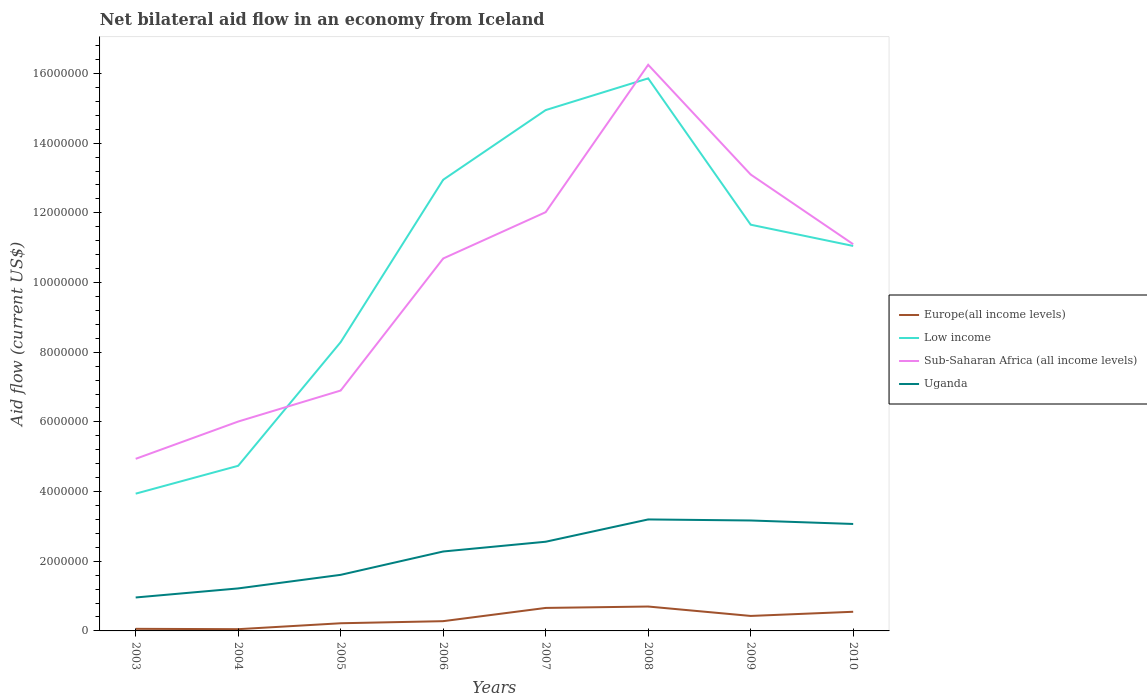How many different coloured lines are there?
Provide a succinct answer. 4. Does the line corresponding to Uganda intersect with the line corresponding to Europe(all income levels)?
Keep it short and to the point. No. Across all years, what is the maximum net bilateral aid flow in Uganda?
Offer a very short reply. 9.60e+05. In which year was the net bilateral aid flow in Uganda maximum?
Provide a short and direct response. 2003. What is the difference between the highest and the second highest net bilateral aid flow in Low income?
Ensure brevity in your answer.  1.19e+07. What is the difference between the highest and the lowest net bilateral aid flow in Uganda?
Offer a terse response. 5. Is the net bilateral aid flow in Low income strictly greater than the net bilateral aid flow in Europe(all income levels) over the years?
Provide a short and direct response. No. How many lines are there?
Your answer should be very brief. 4. How many years are there in the graph?
Provide a short and direct response. 8. Does the graph contain any zero values?
Give a very brief answer. No. Does the graph contain grids?
Give a very brief answer. No. How many legend labels are there?
Offer a very short reply. 4. How are the legend labels stacked?
Provide a succinct answer. Vertical. What is the title of the graph?
Offer a terse response. Net bilateral aid flow in an economy from Iceland. What is the Aid flow (current US$) of Low income in 2003?
Your response must be concise. 3.94e+06. What is the Aid flow (current US$) of Sub-Saharan Africa (all income levels) in 2003?
Offer a terse response. 4.94e+06. What is the Aid flow (current US$) in Uganda in 2003?
Provide a short and direct response. 9.60e+05. What is the Aid flow (current US$) of Low income in 2004?
Make the answer very short. 4.74e+06. What is the Aid flow (current US$) in Sub-Saharan Africa (all income levels) in 2004?
Ensure brevity in your answer.  6.01e+06. What is the Aid flow (current US$) of Uganda in 2004?
Your answer should be compact. 1.22e+06. What is the Aid flow (current US$) of Europe(all income levels) in 2005?
Ensure brevity in your answer.  2.20e+05. What is the Aid flow (current US$) in Low income in 2005?
Ensure brevity in your answer.  8.29e+06. What is the Aid flow (current US$) of Sub-Saharan Africa (all income levels) in 2005?
Your response must be concise. 6.90e+06. What is the Aid flow (current US$) in Uganda in 2005?
Provide a succinct answer. 1.61e+06. What is the Aid flow (current US$) of Europe(all income levels) in 2006?
Give a very brief answer. 2.80e+05. What is the Aid flow (current US$) of Low income in 2006?
Keep it short and to the point. 1.30e+07. What is the Aid flow (current US$) in Sub-Saharan Africa (all income levels) in 2006?
Your answer should be compact. 1.07e+07. What is the Aid flow (current US$) of Uganda in 2006?
Offer a terse response. 2.28e+06. What is the Aid flow (current US$) in Europe(all income levels) in 2007?
Keep it short and to the point. 6.60e+05. What is the Aid flow (current US$) of Low income in 2007?
Give a very brief answer. 1.50e+07. What is the Aid flow (current US$) in Sub-Saharan Africa (all income levels) in 2007?
Keep it short and to the point. 1.20e+07. What is the Aid flow (current US$) of Uganda in 2007?
Keep it short and to the point. 2.56e+06. What is the Aid flow (current US$) in Low income in 2008?
Make the answer very short. 1.59e+07. What is the Aid flow (current US$) in Sub-Saharan Africa (all income levels) in 2008?
Your response must be concise. 1.62e+07. What is the Aid flow (current US$) of Uganda in 2008?
Provide a short and direct response. 3.20e+06. What is the Aid flow (current US$) of Low income in 2009?
Your answer should be very brief. 1.17e+07. What is the Aid flow (current US$) of Sub-Saharan Africa (all income levels) in 2009?
Your answer should be compact. 1.31e+07. What is the Aid flow (current US$) of Uganda in 2009?
Your answer should be very brief. 3.17e+06. What is the Aid flow (current US$) of Europe(all income levels) in 2010?
Your answer should be very brief. 5.50e+05. What is the Aid flow (current US$) of Low income in 2010?
Give a very brief answer. 1.10e+07. What is the Aid flow (current US$) in Sub-Saharan Africa (all income levels) in 2010?
Keep it short and to the point. 1.11e+07. What is the Aid flow (current US$) of Uganda in 2010?
Your answer should be very brief. 3.07e+06. Across all years, what is the maximum Aid flow (current US$) of Europe(all income levels)?
Provide a succinct answer. 7.00e+05. Across all years, what is the maximum Aid flow (current US$) in Low income?
Your answer should be very brief. 1.59e+07. Across all years, what is the maximum Aid flow (current US$) in Sub-Saharan Africa (all income levels)?
Offer a terse response. 1.62e+07. Across all years, what is the maximum Aid flow (current US$) of Uganda?
Ensure brevity in your answer.  3.20e+06. Across all years, what is the minimum Aid flow (current US$) of Europe(all income levels)?
Your answer should be compact. 5.00e+04. Across all years, what is the minimum Aid flow (current US$) in Low income?
Provide a succinct answer. 3.94e+06. Across all years, what is the minimum Aid flow (current US$) in Sub-Saharan Africa (all income levels)?
Your answer should be very brief. 4.94e+06. Across all years, what is the minimum Aid flow (current US$) in Uganda?
Give a very brief answer. 9.60e+05. What is the total Aid flow (current US$) in Europe(all income levels) in the graph?
Give a very brief answer. 2.95e+06. What is the total Aid flow (current US$) of Low income in the graph?
Make the answer very short. 8.34e+07. What is the total Aid flow (current US$) of Sub-Saharan Africa (all income levels) in the graph?
Your answer should be compact. 8.10e+07. What is the total Aid flow (current US$) in Uganda in the graph?
Your answer should be compact. 1.81e+07. What is the difference between the Aid flow (current US$) in Low income in 2003 and that in 2004?
Your answer should be compact. -8.00e+05. What is the difference between the Aid flow (current US$) in Sub-Saharan Africa (all income levels) in 2003 and that in 2004?
Ensure brevity in your answer.  -1.07e+06. What is the difference between the Aid flow (current US$) in Europe(all income levels) in 2003 and that in 2005?
Provide a succinct answer. -1.60e+05. What is the difference between the Aid flow (current US$) of Low income in 2003 and that in 2005?
Your answer should be very brief. -4.35e+06. What is the difference between the Aid flow (current US$) of Sub-Saharan Africa (all income levels) in 2003 and that in 2005?
Make the answer very short. -1.96e+06. What is the difference between the Aid flow (current US$) in Uganda in 2003 and that in 2005?
Offer a very short reply. -6.50e+05. What is the difference between the Aid flow (current US$) of Low income in 2003 and that in 2006?
Ensure brevity in your answer.  -9.01e+06. What is the difference between the Aid flow (current US$) of Sub-Saharan Africa (all income levels) in 2003 and that in 2006?
Give a very brief answer. -5.75e+06. What is the difference between the Aid flow (current US$) in Uganda in 2003 and that in 2006?
Your response must be concise. -1.32e+06. What is the difference between the Aid flow (current US$) of Europe(all income levels) in 2003 and that in 2007?
Your response must be concise. -6.00e+05. What is the difference between the Aid flow (current US$) in Low income in 2003 and that in 2007?
Offer a terse response. -1.10e+07. What is the difference between the Aid flow (current US$) of Sub-Saharan Africa (all income levels) in 2003 and that in 2007?
Your answer should be compact. -7.08e+06. What is the difference between the Aid flow (current US$) of Uganda in 2003 and that in 2007?
Make the answer very short. -1.60e+06. What is the difference between the Aid flow (current US$) in Europe(all income levels) in 2003 and that in 2008?
Offer a very short reply. -6.40e+05. What is the difference between the Aid flow (current US$) of Low income in 2003 and that in 2008?
Your response must be concise. -1.19e+07. What is the difference between the Aid flow (current US$) in Sub-Saharan Africa (all income levels) in 2003 and that in 2008?
Provide a succinct answer. -1.13e+07. What is the difference between the Aid flow (current US$) of Uganda in 2003 and that in 2008?
Keep it short and to the point. -2.24e+06. What is the difference between the Aid flow (current US$) in Europe(all income levels) in 2003 and that in 2009?
Offer a terse response. -3.70e+05. What is the difference between the Aid flow (current US$) of Low income in 2003 and that in 2009?
Keep it short and to the point. -7.72e+06. What is the difference between the Aid flow (current US$) of Sub-Saharan Africa (all income levels) in 2003 and that in 2009?
Ensure brevity in your answer.  -8.16e+06. What is the difference between the Aid flow (current US$) in Uganda in 2003 and that in 2009?
Provide a succinct answer. -2.21e+06. What is the difference between the Aid flow (current US$) of Europe(all income levels) in 2003 and that in 2010?
Keep it short and to the point. -4.90e+05. What is the difference between the Aid flow (current US$) of Low income in 2003 and that in 2010?
Make the answer very short. -7.11e+06. What is the difference between the Aid flow (current US$) in Sub-Saharan Africa (all income levels) in 2003 and that in 2010?
Provide a succinct answer. -6.16e+06. What is the difference between the Aid flow (current US$) of Uganda in 2003 and that in 2010?
Provide a short and direct response. -2.11e+06. What is the difference between the Aid flow (current US$) in Europe(all income levels) in 2004 and that in 2005?
Make the answer very short. -1.70e+05. What is the difference between the Aid flow (current US$) in Low income in 2004 and that in 2005?
Your answer should be compact. -3.55e+06. What is the difference between the Aid flow (current US$) in Sub-Saharan Africa (all income levels) in 2004 and that in 2005?
Offer a very short reply. -8.90e+05. What is the difference between the Aid flow (current US$) of Uganda in 2004 and that in 2005?
Offer a terse response. -3.90e+05. What is the difference between the Aid flow (current US$) of Low income in 2004 and that in 2006?
Your response must be concise. -8.21e+06. What is the difference between the Aid flow (current US$) of Sub-Saharan Africa (all income levels) in 2004 and that in 2006?
Give a very brief answer. -4.68e+06. What is the difference between the Aid flow (current US$) in Uganda in 2004 and that in 2006?
Keep it short and to the point. -1.06e+06. What is the difference between the Aid flow (current US$) of Europe(all income levels) in 2004 and that in 2007?
Your response must be concise. -6.10e+05. What is the difference between the Aid flow (current US$) of Low income in 2004 and that in 2007?
Keep it short and to the point. -1.02e+07. What is the difference between the Aid flow (current US$) of Sub-Saharan Africa (all income levels) in 2004 and that in 2007?
Ensure brevity in your answer.  -6.01e+06. What is the difference between the Aid flow (current US$) of Uganda in 2004 and that in 2007?
Your answer should be very brief. -1.34e+06. What is the difference between the Aid flow (current US$) of Europe(all income levels) in 2004 and that in 2008?
Your response must be concise. -6.50e+05. What is the difference between the Aid flow (current US$) in Low income in 2004 and that in 2008?
Ensure brevity in your answer.  -1.11e+07. What is the difference between the Aid flow (current US$) in Sub-Saharan Africa (all income levels) in 2004 and that in 2008?
Provide a succinct answer. -1.02e+07. What is the difference between the Aid flow (current US$) in Uganda in 2004 and that in 2008?
Your answer should be very brief. -1.98e+06. What is the difference between the Aid flow (current US$) of Europe(all income levels) in 2004 and that in 2009?
Make the answer very short. -3.80e+05. What is the difference between the Aid flow (current US$) in Low income in 2004 and that in 2009?
Your answer should be compact. -6.92e+06. What is the difference between the Aid flow (current US$) of Sub-Saharan Africa (all income levels) in 2004 and that in 2009?
Offer a very short reply. -7.09e+06. What is the difference between the Aid flow (current US$) in Uganda in 2004 and that in 2009?
Make the answer very short. -1.95e+06. What is the difference between the Aid flow (current US$) of Europe(all income levels) in 2004 and that in 2010?
Your response must be concise. -5.00e+05. What is the difference between the Aid flow (current US$) of Low income in 2004 and that in 2010?
Your response must be concise. -6.31e+06. What is the difference between the Aid flow (current US$) in Sub-Saharan Africa (all income levels) in 2004 and that in 2010?
Offer a very short reply. -5.09e+06. What is the difference between the Aid flow (current US$) in Uganda in 2004 and that in 2010?
Ensure brevity in your answer.  -1.85e+06. What is the difference between the Aid flow (current US$) of Low income in 2005 and that in 2006?
Provide a short and direct response. -4.66e+06. What is the difference between the Aid flow (current US$) of Sub-Saharan Africa (all income levels) in 2005 and that in 2006?
Give a very brief answer. -3.79e+06. What is the difference between the Aid flow (current US$) of Uganda in 2005 and that in 2006?
Offer a very short reply. -6.70e+05. What is the difference between the Aid flow (current US$) of Europe(all income levels) in 2005 and that in 2007?
Ensure brevity in your answer.  -4.40e+05. What is the difference between the Aid flow (current US$) of Low income in 2005 and that in 2007?
Ensure brevity in your answer.  -6.66e+06. What is the difference between the Aid flow (current US$) in Sub-Saharan Africa (all income levels) in 2005 and that in 2007?
Your answer should be compact. -5.12e+06. What is the difference between the Aid flow (current US$) in Uganda in 2005 and that in 2007?
Offer a very short reply. -9.50e+05. What is the difference between the Aid flow (current US$) in Europe(all income levels) in 2005 and that in 2008?
Ensure brevity in your answer.  -4.80e+05. What is the difference between the Aid flow (current US$) of Low income in 2005 and that in 2008?
Your response must be concise. -7.57e+06. What is the difference between the Aid flow (current US$) of Sub-Saharan Africa (all income levels) in 2005 and that in 2008?
Make the answer very short. -9.35e+06. What is the difference between the Aid flow (current US$) of Uganda in 2005 and that in 2008?
Give a very brief answer. -1.59e+06. What is the difference between the Aid flow (current US$) of Europe(all income levels) in 2005 and that in 2009?
Ensure brevity in your answer.  -2.10e+05. What is the difference between the Aid flow (current US$) of Low income in 2005 and that in 2009?
Ensure brevity in your answer.  -3.37e+06. What is the difference between the Aid flow (current US$) in Sub-Saharan Africa (all income levels) in 2005 and that in 2009?
Your answer should be compact. -6.20e+06. What is the difference between the Aid flow (current US$) in Uganda in 2005 and that in 2009?
Give a very brief answer. -1.56e+06. What is the difference between the Aid flow (current US$) in Europe(all income levels) in 2005 and that in 2010?
Offer a terse response. -3.30e+05. What is the difference between the Aid flow (current US$) of Low income in 2005 and that in 2010?
Your response must be concise. -2.76e+06. What is the difference between the Aid flow (current US$) in Sub-Saharan Africa (all income levels) in 2005 and that in 2010?
Offer a very short reply. -4.20e+06. What is the difference between the Aid flow (current US$) in Uganda in 2005 and that in 2010?
Your response must be concise. -1.46e+06. What is the difference between the Aid flow (current US$) in Europe(all income levels) in 2006 and that in 2007?
Make the answer very short. -3.80e+05. What is the difference between the Aid flow (current US$) of Sub-Saharan Africa (all income levels) in 2006 and that in 2007?
Ensure brevity in your answer.  -1.33e+06. What is the difference between the Aid flow (current US$) in Uganda in 2006 and that in 2007?
Offer a very short reply. -2.80e+05. What is the difference between the Aid flow (current US$) of Europe(all income levels) in 2006 and that in 2008?
Your answer should be compact. -4.20e+05. What is the difference between the Aid flow (current US$) in Low income in 2006 and that in 2008?
Provide a succinct answer. -2.91e+06. What is the difference between the Aid flow (current US$) in Sub-Saharan Africa (all income levels) in 2006 and that in 2008?
Keep it short and to the point. -5.56e+06. What is the difference between the Aid flow (current US$) in Uganda in 2006 and that in 2008?
Offer a very short reply. -9.20e+05. What is the difference between the Aid flow (current US$) of Europe(all income levels) in 2006 and that in 2009?
Give a very brief answer. -1.50e+05. What is the difference between the Aid flow (current US$) of Low income in 2006 and that in 2009?
Offer a very short reply. 1.29e+06. What is the difference between the Aid flow (current US$) in Sub-Saharan Africa (all income levels) in 2006 and that in 2009?
Keep it short and to the point. -2.41e+06. What is the difference between the Aid flow (current US$) of Uganda in 2006 and that in 2009?
Your response must be concise. -8.90e+05. What is the difference between the Aid flow (current US$) of Low income in 2006 and that in 2010?
Provide a short and direct response. 1.90e+06. What is the difference between the Aid flow (current US$) of Sub-Saharan Africa (all income levels) in 2006 and that in 2010?
Provide a succinct answer. -4.10e+05. What is the difference between the Aid flow (current US$) of Uganda in 2006 and that in 2010?
Ensure brevity in your answer.  -7.90e+05. What is the difference between the Aid flow (current US$) in Low income in 2007 and that in 2008?
Your answer should be very brief. -9.10e+05. What is the difference between the Aid flow (current US$) in Sub-Saharan Africa (all income levels) in 2007 and that in 2008?
Ensure brevity in your answer.  -4.23e+06. What is the difference between the Aid flow (current US$) in Uganda in 2007 and that in 2008?
Provide a succinct answer. -6.40e+05. What is the difference between the Aid flow (current US$) in Europe(all income levels) in 2007 and that in 2009?
Provide a short and direct response. 2.30e+05. What is the difference between the Aid flow (current US$) in Low income in 2007 and that in 2009?
Your response must be concise. 3.29e+06. What is the difference between the Aid flow (current US$) in Sub-Saharan Africa (all income levels) in 2007 and that in 2009?
Provide a short and direct response. -1.08e+06. What is the difference between the Aid flow (current US$) in Uganda in 2007 and that in 2009?
Offer a terse response. -6.10e+05. What is the difference between the Aid flow (current US$) in Low income in 2007 and that in 2010?
Keep it short and to the point. 3.90e+06. What is the difference between the Aid flow (current US$) of Sub-Saharan Africa (all income levels) in 2007 and that in 2010?
Offer a terse response. 9.20e+05. What is the difference between the Aid flow (current US$) in Uganda in 2007 and that in 2010?
Give a very brief answer. -5.10e+05. What is the difference between the Aid flow (current US$) in Europe(all income levels) in 2008 and that in 2009?
Give a very brief answer. 2.70e+05. What is the difference between the Aid flow (current US$) of Low income in 2008 and that in 2009?
Offer a very short reply. 4.20e+06. What is the difference between the Aid flow (current US$) of Sub-Saharan Africa (all income levels) in 2008 and that in 2009?
Your answer should be compact. 3.15e+06. What is the difference between the Aid flow (current US$) of Uganda in 2008 and that in 2009?
Provide a short and direct response. 3.00e+04. What is the difference between the Aid flow (current US$) of Europe(all income levels) in 2008 and that in 2010?
Offer a terse response. 1.50e+05. What is the difference between the Aid flow (current US$) in Low income in 2008 and that in 2010?
Your answer should be very brief. 4.81e+06. What is the difference between the Aid flow (current US$) of Sub-Saharan Africa (all income levels) in 2008 and that in 2010?
Keep it short and to the point. 5.15e+06. What is the difference between the Aid flow (current US$) of Uganda in 2008 and that in 2010?
Your answer should be very brief. 1.30e+05. What is the difference between the Aid flow (current US$) of Europe(all income levels) in 2009 and that in 2010?
Give a very brief answer. -1.20e+05. What is the difference between the Aid flow (current US$) of Europe(all income levels) in 2003 and the Aid flow (current US$) of Low income in 2004?
Offer a terse response. -4.68e+06. What is the difference between the Aid flow (current US$) in Europe(all income levels) in 2003 and the Aid flow (current US$) in Sub-Saharan Africa (all income levels) in 2004?
Offer a terse response. -5.95e+06. What is the difference between the Aid flow (current US$) in Europe(all income levels) in 2003 and the Aid flow (current US$) in Uganda in 2004?
Ensure brevity in your answer.  -1.16e+06. What is the difference between the Aid flow (current US$) in Low income in 2003 and the Aid flow (current US$) in Sub-Saharan Africa (all income levels) in 2004?
Your response must be concise. -2.07e+06. What is the difference between the Aid flow (current US$) in Low income in 2003 and the Aid flow (current US$) in Uganda in 2004?
Offer a terse response. 2.72e+06. What is the difference between the Aid flow (current US$) in Sub-Saharan Africa (all income levels) in 2003 and the Aid flow (current US$) in Uganda in 2004?
Your answer should be very brief. 3.72e+06. What is the difference between the Aid flow (current US$) of Europe(all income levels) in 2003 and the Aid flow (current US$) of Low income in 2005?
Your answer should be compact. -8.23e+06. What is the difference between the Aid flow (current US$) in Europe(all income levels) in 2003 and the Aid flow (current US$) in Sub-Saharan Africa (all income levels) in 2005?
Provide a short and direct response. -6.84e+06. What is the difference between the Aid flow (current US$) in Europe(all income levels) in 2003 and the Aid flow (current US$) in Uganda in 2005?
Offer a terse response. -1.55e+06. What is the difference between the Aid flow (current US$) in Low income in 2003 and the Aid flow (current US$) in Sub-Saharan Africa (all income levels) in 2005?
Ensure brevity in your answer.  -2.96e+06. What is the difference between the Aid flow (current US$) of Low income in 2003 and the Aid flow (current US$) of Uganda in 2005?
Give a very brief answer. 2.33e+06. What is the difference between the Aid flow (current US$) of Sub-Saharan Africa (all income levels) in 2003 and the Aid flow (current US$) of Uganda in 2005?
Provide a short and direct response. 3.33e+06. What is the difference between the Aid flow (current US$) of Europe(all income levels) in 2003 and the Aid flow (current US$) of Low income in 2006?
Ensure brevity in your answer.  -1.29e+07. What is the difference between the Aid flow (current US$) in Europe(all income levels) in 2003 and the Aid flow (current US$) in Sub-Saharan Africa (all income levels) in 2006?
Ensure brevity in your answer.  -1.06e+07. What is the difference between the Aid flow (current US$) of Europe(all income levels) in 2003 and the Aid flow (current US$) of Uganda in 2006?
Provide a succinct answer. -2.22e+06. What is the difference between the Aid flow (current US$) in Low income in 2003 and the Aid flow (current US$) in Sub-Saharan Africa (all income levels) in 2006?
Provide a short and direct response. -6.75e+06. What is the difference between the Aid flow (current US$) of Low income in 2003 and the Aid flow (current US$) of Uganda in 2006?
Offer a very short reply. 1.66e+06. What is the difference between the Aid flow (current US$) of Sub-Saharan Africa (all income levels) in 2003 and the Aid flow (current US$) of Uganda in 2006?
Keep it short and to the point. 2.66e+06. What is the difference between the Aid flow (current US$) of Europe(all income levels) in 2003 and the Aid flow (current US$) of Low income in 2007?
Provide a short and direct response. -1.49e+07. What is the difference between the Aid flow (current US$) of Europe(all income levels) in 2003 and the Aid flow (current US$) of Sub-Saharan Africa (all income levels) in 2007?
Give a very brief answer. -1.20e+07. What is the difference between the Aid flow (current US$) of Europe(all income levels) in 2003 and the Aid flow (current US$) of Uganda in 2007?
Offer a very short reply. -2.50e+06. What is the difference between the Aid flow (current US$) of Low income in 2003 and the Aid flow (current US$) of Sub-Saharan Africa (all income levels) in 2007?
Offer a terse response. -8.08e+06. What is the difference between the Aid flow (current US$) in Low income in 2003 and the Aid flow (current US$) in Uganda in 2007?
Provide a short and direct response. 1.38e+06. What is the difference between the Aid flow (current US$) in Sub-Saharan Africa (all income levels) in 2003 and the Aid flow (current US$) in Uganda in 2007?
Your answer should be very brief. 2.38e+06. What is the difference between the Aid flow (current US$) of Europe(all income levels) in 2003 and the Aid flow (current US$) of Low income in 2008?
Keep it short and to the point. -1.58e+07. What is the difference between the Aid flow (current US$) of Europe(all income levels) in 2003 and the Aid flow (current US$) of Sub-Saharan Africa (all income levels) in 2008?
Ensure brevity in your answer.  -1.62e+07. What is the difference between the Aid flow (current US$) in Europe(all income levels) in 2003 and the Aid flow (current US$) in Uganda in 2008?
Offer a terse response. -3.14e+06. What is the difference between the Aid flow (current US$) of Low income in 2003 and the Aid flow (current US$) of Sub-Saharan Africa (all income levels) in 2008?
Offer a very short reply. -1.23e+07. What is the difference between the Aid flow (current US$) of Low income in 2003 and the Aid flow (current US$) of Uganda in 2008?
Ensure brevity in your answer.  7.40e+05. What is the difference between the Aid flow (current US$) of Sub-Saharan Africa (all income levels) in 2003 and the Aid flow (current US$) of Uganda in 2008?
Offer a very short reply. 1.74e+06. What is the difference between the Aid flow (current US$) of Europe(all income levels) in 2003 and the Aid flow (current US$) of Low income in 2009?
Provide a short and direct response. -1.16e+07. What is the difference between the Aid flow (current US$) in Europe(all income levels) in 2003 and the Aid flow (current US$) in Sub-Saharan Africa (all income levels) in 2009?
Offer a very short reply. -1.30e+07. What is the difference between the Aid flow (current US$) of Europe(all income levels) in 2003 and the Aid flow (current US$) of Uganda in 2009?
Make the answer very short. -3.11e+06. What is the difference between the Aid flow (current US$) of Low income in 2003 and the Aid flow (current US$) of Sub-Saharan Africa (all income levels) in 2009?
Keep it short and to the point. -9.16e+06. What is the difference between the Aid flow (current US$) of Low income in 2003 and the Aid flow (current US$) of Uganda in 2009?
Keep it short and to the point. 7.70e+05. What is the difference between the Aid flow (current US$) in Sub-Saharan Africa (all income levels) in 2003 and the Aid flow (current US$) in Uganda in 2009?
Your answer should be very brief. 1.77e+06. What is the difference between the Aid flow (current US$) in Europe(all income levels) in 2003 and the Aid flow (current US$) in Low income in 2010?
Your answer should be compact. -1.10e+07. What is the difference between the Aid flow (current US$) of Europe(all income levels) in 2003 and the Aid flow (current US$) of Sub-Saharan Africa (all income levels) in 2010?
Your response must be concise. -1.10e+07. What is the difference between the Aid flow (current US$) in Europe(all income levels) in 2003 and the Aid flow (current US$) in Uganda in 2010?
Make the answer very short. -3.01e+06. What is the difference between the Aid flow (current US$) in Low income in 2003 and the Aid flow (current US$) in Sub-Saharan Africa (all income levels) in 2010?
Provide a succinct answer. -7.16e+06. What is the difference between the Aid flow (current US$) of Low income in 2003 and the Aid flow (current US$) of Uganda in 2010?
Provide a short and direct response. 8.70e+05. What is the difference between the Aid flow (current US$) in Sub-Saharan Africa (all income levels) in 2003 and the Aid flow (current US$) in Uganda in 2010?
Make the answer very short. 1.87e+06. What is the difference between the Aid flow (current US$) of Europe(all income levels) in 2004 and the Aid flow (current US$) of Low income in 2005?
Offer a very short reply. -8.24e+06. What is the difference between the Aid flow (current US$) in Europe(all income levels) in 2004 and the Aid flow (current US$) in Sub-Saharan Africa (all income levels) in 2005?
Provide a short and direct response. -6.85e+06. What is the difference between the Aid flow (current US$) of Europe(all income levels) in 2004 and the Aid flow (current US$) of Uganda in 2005?
Your response must be concise. -1.56e+06. What is the difference between the Aid flow (current US$) of Low income in 2004 and the Aid flow (current US$) of Sub-Saharan Africa (all income levels) in 2005?
Provide a short and direct response. -2.16e+06. What is the difference between the Aid flow (current US$) in Low income in 2004 and the Aid flow (current US$) in Uganda in 2005?
Keep it short and to the point. 3.13e+06. What is the difference between the Aid flow (current US$) in Sub-Saharan Africa (all income levels) in 2004 and the Aid flow (current US$) in Uganda in 2005?
Keep it short and to the point. 4.40e+06. What is the difference between the Aid flow (current US$) in Europe(all income levels) in 2004 and the Aid flow (current US$) in Low income in 2006?
Keep it short and to the point. -1.29e+07. What is the difference between the Aid flow (current US$) in Europe(all income levels) in 2004 and the Aid flow (current US$) in Sub-Saharan Africa (all income levels) in 2006?
Offer a terse response. -1.06e+07. What is the difference between the Aid flow (current US$) in Europe(all income levels) in 2004 and the Aid flow (current US$) in Uganda in 2006?
Give a very brief answer. -2.23e+06. What is the difference between the Aid flow (current US$) of Low income in 2004 and the Aid flow (current US$) of Sub-Saharan Africa (all income levels) in 2006?
Offer a very short reply. -5.95e+06. What is the difference between the Aid flow (current US$) of Low income in 2004 and the Aid flow (current US$) of Uganda in 2006?
Your answer should be very brief. 2.46e+06. What is the difference between the Aid flow (current US$) in Sub-Saharan Africa (all income levels) in 2004 and the Aid flow (current US$) in Uganda in 2006?
Offer a very short reply. 3.73e+06. What is the difference between the Aid flow (current US$) in Europe(all income levels) in 2004 and the Aid flow (current US$) in Low income in 2007?
Your response must be concise. -1.49e+07. What is the difference between the Aid flow (current US$) in Europe(all income levels) in 2004 and the Aid flow (current US$) in Sub-Saharan Africa (all income levels) in 2007?
Provide a succinct answer. -1.20e+07. What is the difference between the Aid flow (current US$) of Europe(all income levels) in 2004 and the Aid flow (current US$) of Uganda in 2007?
Your response must be concise. -2.51e+06. What is the difference between the Aid flow (current US$) of Low income in 2004 and the Aid flow (current US$) of Sub-Saharan Africa (all income levels) in 2007?
Give a very brief answer. -7.28e+06. What is the difference between the Aid flow (current US$) in Low income in 2004 and the Aid flow (current US$) in Uganda in 2007?
Provide a succinct answer. 2.18e+06. What is the difference between the Aid flow (current US$) in Sub-Saharan Africa (all income levels) in 2004 and the Aid flow (current US$) in Uganda in 2007?
Provide a succinct answer. 3.45e+06. What is the difference between the Aid flow (current US$) in Europe(all income levels) in 2004 and the Aid flow (current US$) in Low income in 2008?
Your answer should be very brief. -1.58e+07. What is the difference between the Aid flow (current US$) of Europe(all income levels) in 2004 and the Aid flow (current US$) of Sub-Saharan Africa (all income levels) in 2008?
Ensure brevity in your answer.  -1.62e+07. What is the difference between the Aid flow (current US$) of Europe(all income levels) in 2004 and the Aid flow (current US$) of Uganda in 2008?
Give a very brief answer. -3.15e+06. What is the difference between the Aid flow (current US$) of Low income in 2004 and the Aid flow (current US$) of Sub-Saharan Africa (all income levels) in 2008?
Offer a very short reply. -1.15e+07. What is the difference between the Aid flow (current US$) of Low income in 2004 and the Aid flow (current US$) of Uganda in 2008?
Ensure brevity in your answer.  1.54e+06. What is the difference between the Aid flow (current US$) in Sub-Saharan Africa (all income levels) in 2004 and the Aid flow (current US$) in Uganda in 2008?
Provide a short and direct response. 2.81e+06. What is the difference between the Aid flow (current US$) in Europe(all income levels) in 2004 and the Aid flow (current US$) in Low income in 2009?
Keep it short and to the point. -1.16e+07. What is the difference between the Aid flow (current US$) of Europe(all income levels) in 2004 and the Aid flow (current US$) of Sub-Saharan Africa (all income levels) in 2009?
Provide a short and direct response. -1.30e+07. What is the difference between the Aid flow (current US$) of Europe(all income levels) in 2004 and the Aid flow (current US$) of Uganda in 2009?
Offer a very short reply. -3.12e+06. What is the difference between the Aid flow (current US$) of Low income in 2004 and the Aid flow (current US$) of Sub-Saharan Africa (all income levels) in 2009?
Your response must be concise. -8.36e+06. What is the difference between the Aid flow (current US$) of Low income in 2004 and the Aid flow (current US$) of Uganda in 2009?
Make the answer very short. 1.57e+06. What is the difference between the Aid flow (current US$) of Sub-Saharan Africa (all income levels) in 2004 and the Aid flow (current US$) of Uganda in 2009?
Offer a terse response. 2.84e+06. What is the difference between the Aid flow (current US$) in Europe(all income levels) in 2004 and the Aid flow (current US$) in Low income in 2010?
Your response must be concise. -1.10e+07. What is the difference between the Aid flow (current US$) of Europe(all income levels) in 2004 and the Aid flow (current US$) of Sub-Saharan Africa (all income levels) in 2010?
Your answer should be compact. -1.10e+07. What is the difference between the Aid flow (current US$) in Europe(all income levels) in 2004 and the Aid flow (current US$) in Uganda in 2010?
Provide a short and direct response. -3.02e+06. What is the difference between the Aid flow (current US$) in Low income in 2004 and the Aid flow (current US$) in Sub-Saharan Africa (all income levels) in 2010?
Keep it short and to the point. -6.36e+06. What is the difference between the Aid flow (current US$) in Low income in 2004 and the Aid flow (current US$) in Uganda in 2010?
Ensure brevity in your answer.  1.67e+06. What is the difference between the Aid flow (current US$) of Sub-Saharan Africa (all income levels) in 2004 and the Aid flow (current US$) of Uganda in 2010?
Ensure brevity in your answer.  2.94e+06. What is the difference between the Aid flow (current US$) in Europe(all income levels) in 2005 and the Aid flow (current US$) in Low income in 2006?
Provide a succinct answer. -1.27e+07. What is the difference between the Aid flow (current US$) in Europe(all income levels) in 2005 and the Aid flow (current US$) in Sub-Saharan Africa (all income levels) in 2006?
Your answer should be compact. -1.05e+07. What is the difference between the Aid flow (current US$) in Europe(all income levels) in 2005 and the Aid flow (current US$) in Uganda in 2006?
Offer a very short reply. -2.06e+06. What is the difference between the Aid flow (current US$) of Low income in 2005 and the Aid flow (current US$) of Sub-Saharan Africa (all income levels) in 2006?
Your answer should be very brief. -2.40e+06. What is the difference between the Aid flow (current US$) in Low income in 2005 and the Aid flow (current US$) in Uganda in 2006?
Provide a short and direct response. 6.01e+06. What is the difference between the Aid flow (current US$) of Sub-Saharan Africa (all income levels) in 2005 and the Aid flow (current US$) of Uganda in 2006?
Provide a short and direct response. 4.62e+06. What is the difference between the Aid flow (current US$) of Europe(all income levels) in 2005 and the Aid flow (current US$) of Low income in 2007?
Offer a terse response. -1.47e+07. What is the difference between the Aid flow (current US$) of Europe(all income levels) in 2005 and the Aid flow (current US$) of Sub-Saharan Africa (all income levels) in 2007?
Your answer should be compact. -1.18e+07. What is the difference between the Aid flow (current US$) of Europe(all income levels) in 2005 and the Aid flow (current US$) of Uganda in 2007?
Offer a very short reply. -2.34e+06. What is the difference between the Aid flow (current US$) in Low income in 2005 and the Aid flow (current US$) in Sub-Saharan Africa (all income levels) in 2007?
Your answer should be very brief. -3.73e+06. What is the difference between the Aid flow (current US$) of Low income in 2005 and the Aid flow (current US$) of Uganda in 2007?
Provide a succinct answer. 5.73e+06. What is the difference between the Aid flow (current US$) of Sub-Saharan Africa (all income levels) in 2005 and the Aid flow (current US$) of Uganda in 2007?
Ensure brevity in your answer.  4.34e+06. What is the difference between the Aid flow (current US$) of Europe(all income levels) in 2005 and the Aid flow (current US$) of Low income in 2008?
Provide a succinct answer. -1.56e+07. What is the difference between the Aid flow (current US$) of Europe(all income levels) in 2005 and the Aid flow (current US$) of Sub-Saharan Africa (all income levels) in 2008?
Make the answer very short. -1.60e+07. What is the difference between the Aid flow (current US$) of Europe(all income levels) in 2005 and the Aid flow (current US$) of Uganda in 2008?
Your response must be concise. -2.98e+06. What is the difference between the Aid flow (current US$) in Low income in 2005 and the Aid flow (current US$) in Sub-Saharan Africa (all income levels) in 2008?
Give a very brief answer. -7.96e+06. What is the difference between the Aid flow (current US$) of Low income in 2005 and the Aid flow (current US$) of Uganda in 2008?
Your answer should be very brief. 5.09e+06. What is the difference between the Aid flow (current US$) of Sub-Saharan Africa (all income levels) in 2005 and the Aid flow (current US$) of Uganda in 2008?
Provide a short and direct response. 3.70e+06. What is the difference between the Aid flow (current US$) of Europe(all income levels) in 2005 and the Aid flow (current US$) of Low income in 2009?
Give a very brief answer. -1.14e+07. What is the difference between the Aid flow (current US$) in Europe(all income levels) in 2005 and the Aid flow (current US$) in Sub-Saharan Africa (all income levels) in 2009?
Provide a succinct answer. -1.29e+07. What is the difference between the Aid flow (current US$) of Europe(all income levels) in 2005 and the Aid flow (current US$) of Uganda in 2009?
Make the answer very short. -2.95e+06. What is the difference between the Aid flow (current US$) of Low income in 2005 and the Aid flow (current US$) of Sub-Saharan Africa (all income levels) in 2009?
Provide a short and direct response. -4.81e+06. What is the difference between the Aid flow (current US$) of Low income in 2005 and the Aid flow (current US$) of Uganda in 2009?
Give a very brief answer. 5.12e+06. What is the difference between the Aid flow (current US$) of Sub-Saharan Africa (all income levels) in 2005 and the Aid flow (current US$) of Uganda in 2009?
Your answer should be very brief. 3.73e+06. What is the difference between the Aid flow (current US$) of Europe(all income levels) in 2005 and the Aid flow (current US$) of Low income in 2010?
Provide a succinct answer. -1.08e+07. What is the difference between the Aid flow (current US$) in Europe(all income levels) in 2005 and the Aid flow (current US$) in Sub-Saharan Africa (all income levels) in 2010?
Your response must be concise. -1.09e+07. What is the difference between the Aid flow (current US$) in Europe(all income levels) in 2005 and the Aid flow (current US$) in Uganda in 2010?
Offer a terse response. -2.85e+06. What is the difference between the Aid flow (current US$) in Low income in 2005 and the Aid flow (current US$) in Sub-Saharan Africa (all income levels) in 2010?
Provide a succinct answer. -2.81e+06. What is the difference between the Aid flow (current US$) in Low income in 2005 and the Aid flow (current US$) in Uganda in 2010?
Give a very brief answer. 5.22e+06. What is the difference between the Aid flow (current US$) in Sub-Saharan Africa (all income levels) in 2005 and the Aid flow (current US$) in Uganda in 2010?
Make the answer very short. 3.83e+06. What is the difference between the Aid flow (current US$) in Europe(all income levels) in 2006 and the Aid flow (current US$) in Low income in 2007?
Offer a terse response. -1.47e+07. What is the difference between the Aid flow (current US$) in Europe(all income levels) in 2006 and the Aid flow (current US$) in Sub-Saharan Africa (all income levels) in 2007?
Give a very brief answer. -1.17e+07. What is the difference between the Aid flow (current US$) of Europe(all income levels) in 2006 and the Aid flow (current US$) of Uganda in 2007?
Your answer should be very brief. -2.28e+06. What is the difference between the Aid flow (current US$) in Low income in 2006 and the Aid flow (current US$) in Sub-Saharan Africa (all income levels) in 2007?
Your answer should be compact. 9.30e+05. What is the difference between the Aid flow (current US$) in Low income in 2006 and the Aid flow (current US$) in Uganda in 2007?
Provide a succinct answer. 1.04e+07. What is the difference between the Aid flow (current US$) of Sub-Saharan Africa (all income levels) in 2006 and the Aid flow (current US$) of Uganda in 2007?
Offer a terse response. 8.13e+06. What is the difference between the Aid flow (current US$) of Europe(all income levels) in 2006 and the Aid flow (current US$) of Low income in 2008?
Ensure brevity in your answer.  -1.56e+07. What is the difference between the Aid flow (current US$) of Europe(all income levels) in 2006 and the Aid flow (current US$) of Sub-Saharan Africa (all income levels) in 2008?
Provide a succinct answer. -1.60e+07. What is the difference between the Aid flow (current US$) of Europe(all income levels) in 2006 and the Aid flow (current US$) of Uganda in 2008?
Provide a short and direct response. -2.92e+06. What is the difference between the Aid flow (current US$) of Low income in 2006 and the Aid flow (current US$) of Sub-Saharan Africa (all income levels) in 2008?
Your answer should be compact. -3.30e+06. What is the difference between the Aid flow (current US$) in Low income in 2006 and the Aid flow (current US$) in Uganda in 2008?
Your answer should be compact. 9.75e+06. What is the difference between the Aid flow (current US$) in Sub-Saharan Africa (all income levels) in 2006 and the Aid flow (current US$) in Uganda in 2008?
Keep it short and to the point. 7.49e+06. What is the difference between the Aid flow (current US$) of Europe(all income levels) in 2006 and the Aid flow (current US$) of Low income in 2009?
Ensure brevity in your answer.  -1.14e+07. What is the difference between the Aid flow (current US$) of Europe(all income levels) in 2006 and the Aid flow (current US$) of Sub-Saharan Africa (all income levels) in 2009?
Offer a very short reply. -1.28e+07. What is the difference between the Aid flow (current US$) of Europe(all income levels) in 2006 and the Aid flow (current US$) of Uganda in 2009?
Your answer should be compact. -2.89e+06. What is the difference between the Aid flow (current US$) of Low income in 2006 and the Aid flow (current US$) of Sub-Saharan Africa (all income levels) in 2009?
Your response must be concise. -1.50e+05. What is the difference between the Aid flow (current US$) of Low income in 2006 and the Aid flow (current US$) of Uganda in 2009?
Your answer should be very brief. 9.78e+06. What is the difference between the Aid flow (current US$) of Sub-Saharan Africa (all income levels) in 2006 and the Aid flow (current US$) of Uganda in 2009?
Make the answer very short. 7.52e+06. What is the difference between the Aid flow (current US$) in Europe(all income levels) in 2006 and the Aid flow (current US$) in Low income in 2010?
Provide a succinct answer. -1.08e+07. What is the difference between the Aid flow (current US$) of Europe(all income levels) in 2006 and the Aid flow (current US$) of Sub-Saharan Africa (all income levels) in 2010?
Offer a terse response. -1.08e+07. What is the difference between the Aid flow (current US$) in Europe(all income levels) in 2006 and the Aid flow (current US$) in Uganda in 2010?
Your answer should be compact. -2.79e+06. What is the difference between the Aid flow (current US$) of Low income in 2006 and the Aid flow (current US$) of Sub-Saharan Africa (all income levels) in 2010?
Your answer should be very brief. 1.85e+06. What is the difference between the Aid flow (current US$) in Low income in 2006 and the Aid flow (current US$) in Uganda in 2010?
Provide a succinct answer. 9.88e+06. What is the difference between the Aid flow (current US$) of Sub-Saharan Africa (all income levels) in 2006 and the Aid flow (current US$) of Uganda in 2010?
Your answer should be compact. 7.62e+06. What is the difference between the Aid flow (current US$) of Europe(all income levels) in 2007 and the Aid flow (current US$) of Low income in 2008?
Provide a short and direct response. -1.52e+07. What is the difference between the Aid flow (current US$) in Europe(all income levels) in 2007 and the Aid flow (current US$) in Sub-Saharan Africa (all income levels) in 2008?
Offer a terse response. -1.56e+07. What is the difference between the Aid flow (current US$) in Europe(all income levels) in 2007 and the Aid flow (current US$) in Uganda in 2008?
Offer a very short reply. -2.54e+06. What is the difference between the Aid flow (current US$) in Low income in 2007 and the Aid flow (current US$) in Sub-Saharan Africa (all income levels) in 2008?
Ensure brevity in your answer.  -1.30e+06. What is the difference between the Aid flow (current US$) in Low income in 2007 and the Aid flow (current US$) in Uganda in 2008?
Your answer should be very brief. 1.18e+07. What is the difference between the Aid flow (current US$) in Sub-Saharan Africa (all income levels) in 2007 and the Aid flow (current US$) in Uganda in 2008?
Offer a terse response. 8.82e+06. What is the difference between the Aid flow (current US$) in Europe(all income levels) in 2007 and the Aid flow (current US$) in Low income in 2009?
Ensure brevity in your answer.  -1.10e+07. What is the difference between the Aid flow (current US$) of Europe(all income levels) in 2007 and the Aid flow (current US$) of Sub-Saharan Africa (all income levels) in 2009?
Give a very brief answer. -1.24e+07. What is the difference between the Aid flow (current US$) in Europe(all income levels) in 2007 and the Aid flow (current US$) in Uganda in 2009?
Provide a succinct answer. -2.51e+06. What is the difference between the Aid flow (current US$) of Low income in 2007 and the Aid flow (current US$) of Sub-Saharan Africa (all income levels) in 2009?
Ensure brevity in your answer.  1.85e+06. What is the difference between the Aid flow (current US$) in Low income in 2007 and the Aid flow (current US$) in Uganda in 2009?
Offer a very short reply. 1.18e+07. What is the difference between the Aid flow (current US$) of Sub-Saharan Africa (all income levels) in 2007 and the Aid flow (current US$) of Uganda in 2009?
Your response must be concise. 8.85e+06. What is the difference between the Aid flow (current US$) in Europe(all income levels) in 2007 and the Aid flow (current US$) in Low income in 2010?
Your response must be concise. -1.04e+07. What is the difference between the Aid flow (current US$) in Europe(all income levels) in 2007 and the Aid flow (current US$) in Sub-Saharan Africa (all income levels) in 2010?
Offer a very short reply. -1.04e+07. What is the difference between the Aid flow (current US$) of Europe(all income levels) in 2007 and the Aid flow (current US$) of Uganda in 2010?
Offer a terse response. -2.41e+06. What is the difference between the Aid flow (current US$) in Low income in 2007 and the Aid flow (current US$) in Sub-Saharan Africa (all income levels) in 2010?
Your response must be concise. 3.85e+06. What is the difference between the Aid flow (current US$) of Low income in 2007 and the Aid flow (current US$) of Uganda in 2010?
Your answer should be very brief. 1.19e+07. What is the difference between the Aid flow (current US$) of Sub-Saharan Africa (all income levels) in 2007 and the Aid flow (current US$) of Uganda in 2010?
Offer a very short reply. 8.95e+06. What is the difference between the Aid flow (current US$) in Europe(all income levels) in 2008 and the Aid flow (current US$) in Low income in 2009?
Your answer should be compact. -1.10e+07. What is the difference between the Aid flow (current US$) of Europe(all income levels) in 2008 and the Aid flow (current US$) of Sub-Saharan Africa (all income levels) in 2009?
Provide a succinct answer. -1.24e+07. What is the difference between the Aid flow (current US$) in Europe(all income levels) in 2008 and the Aid flow (current US$) in Uganda in 2009?
Provide a short and direct response. -2.47e+06. What is the difference between the Aid flow (current US$) in Low income in 2008 and the Aid flow (current US$) in Sub-Saharan Africa (all income levels) in 2009?
Your response must be concise. 2.76e+06. What is the difference between the Aid flow (current US$) in Low income in 2008 and the Aid flow (current US$) in Uganda in 2009?
Your answer should be very brief. 1.27e+07. What is the difference between the Aid flow (current US$) of Sub-Saharan Africa (all income levels) in 2008 and the Aid flow (current US$) of Uganda in 2009?
Your answer should be very brief. 1.31e+07. What is the difference between the Aid flow (current US$) of Europe(all income levels) in 2008 and the Aid flow (current US$) of Low income in 2010?
Give a very brief answer. -1.04e+07. What is the difference between the Aid flow (current US$) in Europe(all income levels) in 2008 and the Aid flow (current US$) in Sub-Saharan Africa (all income levels) in 2010?
Keep it short and to the point. -1.04e+07. What is the difference between the Aid flow (current US$) of Europe(all income levels) in 2008 and the Aid flow (current US$) of Uganda in 2010?
Your response must be concise. -2.37e+06. What is the difference between the Aid flow (current US$) of Low income in 2008 and the Aid flow (current US$) of Sub-Saharan Africa (all income levels) in 2010?
Your answer should be very brief. 4.76e+06. What is the difference between the Aid flow (current US$) in Low income in 2008 and the Aid flow (current US$) in Uganda in 2010?
Keep it short and to the point. 1.28e+07. What is the difference between the Aid flow (current US$) of Sub-Saharan Africa (all income levels) in 2008 and the Aid flow (current US$) of Uganda in 2010?
Provide a short and direct response. 1.32e+07. What is the difference between the Aid flow (current US$) of Europe(all income levels) in 2009 and the Aid flow (current US$) of Low income in 2010?
Provide a short and direct response. -1.06e+07. What is the difference between the Aid flow (current US$) of Europe(all income levels) in 2009 and the Aid flow (current US$) of Sub-Saharan Africa (all income levels) in 2010?
Offer a very short reply. -1.07e+07. What is the difference between the Aid flow (current US$) of Europe(all income levels) in 2009 and the Aid flow (current US$) of Uganda in 2010?
Provide a succinct answer. -2.64e+06. What is the difference between the Aid flow (current US$) of Low income in 2009 and the Aid flow (current US$) of Sub-Saharan Africa (all income levels) in 2010?
Ensure brevity in your answer.  5.60e+05. What is the difference between the Aid flow (current US$) in Low income in 2009 and the Aid flow (current US$) in Uganda in 2010?
Offer a very short reply. 8.59e+06. What is the difference between the Aid flow (current US$) of Sub-Saharan Africa (all income levels) in 2009 and the Aid flow (current US$) of Uganda in 2010?
Your response must be concise. 1.00e+07. What is the average Aid flow (current US$) in Europe(all income levels) per year?
Your answer should be compact. 3.69e+05. What is the average Aid flow (current US$) in Low income per year?
Keep it short and to the point. 1.04e+07. What is the average Aid flow (current US$) in Sub-Saharan Africa (all income levels) per year?
Offer a very short reply. 1.01e+07. What is the average Aid flow (current US$) in Uganda per year?
Your answer should be compact. 2.26e+06. In the year 2003, what is the difference between the Aid flow (current US$) of Europe(all income levels) and Aid flow (current US$) of Low income?
Ensure brevity in your answer.  -3.88e+06. In the year 2003, what is the difference between the Aid flow (current US$) in Europe(all income levels) and Aid flow (current US$) in Sub-Saharan Africa (all income levels)?
Make the answer very short. -4.88e+06. In the year 2003, what is the difference between the Aid flow (current US$) in Europe(all income levels) and Aid flow (current US$) in Uganda?
Your response must be concise. -9.00e+05. In the year 2003, what is the difference between the Aid flow (current US$) in Low income and Aid flow (current US$) in Uganda?
Your answer should be compact. 2.98e+06. In the year 2003, what is the difference between the Aid flow (current US$) of Sub-Saharan Africa (all income levels) and Aid flow (current US$) of Uganda?
Offer a very short reply. 3.98e+06. In the year 2004, what is the difference between the Aid flow (current US$) of Europe(all income levels) and Aid flow (current US$) of Low income?
Your answer should be very brief. -4.69e+06. In the year 2004, what is the difference between the Aid flow (current US$) of Europe(all income levels) and Aid flow (current US$) of Sub-Saharan Africa (all income levels)?
Provide a short and direct response. -5.96e+06. In the year 2004, what is the difference between the Aid flow (current US$) of Europe(all income levels) and Aid flow (current US$) of Uganda?
Your answer should be very brief. -1.17e+06. In the year 2004, what is the difference between the Aid flow (current US$) in Low income and Aid flow (current US$) in Sub-Saharan Africa (all income levels)?
Provide a succinct answer. -1.27e+06. In the year 2004, what is the difference between the Aid flow (current US$) in Low income and Aid flow (current US$) in Uganda?
Your answer should be compact. 3.52e+06. In the year 2004, what is the difference between the Aid flow (current US$) in Sub-Saharan Africa (all income levels) and Aid flow (current US$) in Uganda?
Your response must be concise. 4.79e+06. In the year 2005, what is the difference between the Aid flow (current US$) in Europe(all income levels) and Aid flow (current US$) in Low income?
Keep it short and to the point. -8.07e+06. In the year 2005, what is the difference between the Aid flow (current US$) of Europe(all income levels) and Aid flow (current US$) of Sub-Saharan Africa (all income levels)?
Keep it short and to the point. -6.68e+06. In the year 2005, what is the difference between the Aid flow (current US$) in Europe(all income levels) and Aid flow (current US$) in Uganda?
Keep it short and to the point. -1.39e+06. In the year 2005, what is the difference between the Aid flow (current US$) of Low income and Aid flow (current US$) of Sub-Saharan Africa (all income levels)?
Offer a very short reply. 1.39e+06. In the year 2005, what is the difference between the Aid flow (current US$) of Low income and Aid flow (current US$) of Uganda?
Make the answer very short. 6.68e+06. In the year 2005, what is the difference between the Aid flow (current US$) in Sub-Saharan Africa (all income levels) and Aid flow (current US$) in Uganda?
Offer a terse response. 5.29e+06. In the year 2006, what is the difference between the Aid flow (current US$) in Europe(all income levels) and Aid flow (current US$) in Low income?
Your response must be concise. -1.27e+07. In the year 2006, what is the difference between the Aid flow (current US$) in Europe(all income levels) and Aid flow (current US$) in Sub-Saharan Africa (all income levels)?
Offer a terse response. -1.04e+07. In the year 2006, what is the difference between the Aid flow (current US$) of Low income and Aid flow (current US$) of Sub-Saharan Africa (all income levels)?
Offer a terse response. 2.26e+06. In the year 2006, what is the difference between the Aid flow (current US$) of Low income and Aid flow (current US$) of Uganda?
Make the answer very short. 1.07e+07. In the year 2006, what is the difference between the Aid flow (current US$) in Sub-Saharan Africa (all income levels) and Aid flow (current US$) in Uganda?
Give a very brief answer. 8.41e+06. In the year 2007, what is the difference between the Aid flow (current US$) in Europe(all income levels) and Aid flow (current US$) in Low income?
Ensure brevity in your answer.  -1.43e+07. In the year 2007, what is the difference between the Aid flow (current US$) of Europe(all income levels) and Aid flow (current US$) of Sub-Saharan Africa (all income levels)?
Your answer should be compact. -1.14e+07. In the year 2007, what is the difference between the Aid flow (current US$) of Europe(all income levels) and Aid flow (current US$) of Uganda?
Your response must be concise. -1.90e+06. In the year 2007, what is the difference between the Aid flow (current US$) in Low income and Aid flow (current US$) in Sub-Saharan Africa (all income levels)?
Give a very brief answer. 2.93e+06. In the year 2007, what is the difference between the Aid flow (current US$) of Low income and Aid flow (current US$) of Uganda?
Your answer should be very brief. 1.24e+07. In the year 2007, what is the difference between the Aid flow (current US$) in Sub-Saharan Africa (all income levels) and Aid flow (current US$) in Uganda?
Offer a terse response. 9.46e+06. In the year 2008, what is the difference between the Aid flow (current US$) in Europe(all income levels) and Aid flow (current US$) in Low income?
Offer a terse response. -1.52e+07. In the year 2008, what is the difference between the Aid flow (current US$) in Europe(all income levels) and Aid flow (current US$) in Sub-Saharan Africa (all income levels)?
Offer a terse response. -1.56e+07. In the year 2008, what is the difference between the Aid flow (current US$) of Europe(all income levels) and Aid flow (current US$) of Uganda?
Your response must be concise. -2.50e+06. In the year 2008, what is the difference between the Aid flow (current US$) in Low income and Aid flow (current US$) in Sub-Saharan Africa (all income levels)?
Keep it short and to the point. -3.90e+05. In the year 2008, what is the difference between the Aid flow (current US$) of Low income and Aid flow (current US$) of Uganda?
Give a very brief answer. 1.27e+07. In the year 2008, what is the difference between the Aid flow (current US$) of Sub-Saharan Africa (all income levels) and Aid flow (current US$) of Uganda?
Your answer should be compact. 1.30e+07. In the year 2009, what is the difference between the Aid flow (current US$) of Europe(all income levels) and Aid flow (current US$) of Low income?
Give a very brief answer. -1.12e+07. In the year 2009, what is the difference between the Aid flow (current US$) of Europe(all income levels) and Aid flow (current US$) of Sub-Saharan Africa (all income levels)?
Offer a very short reply. -1.27e+07. In the year 2009, what is the difference between the Aid flow (current US$) of Europe(all income levels) and Aid flow (current US$) of Uganda?
Your answer should be very brief. -2.74e+06. In the year 2009, what is the difference between the Aid flow (current US$) in Low income and Aid flow (current US$) in Sub-Saharan Africa (all income levels)?
Keep it short and to the point. -1.44e+06. In the year 2009, what is the difference between the Aid flow (current US$) of Low income and Aid flow (current US$) of Uganda?
Provide a succinct answer. 8.49e+06. In the year 2009, what is the difference between the Aid flow (current US$) in Sub-Saharan Africa (all income levels) and Aid flow (current US$) in Uganda?
Keep it short and to the point. 9.93e+06. In the year 2010, what is the difference between the Aid flow (current US$) in Europe(all income levels) and Aid flow (current US$) in Low income?
Make the answer very short. -1.05e+07. In the year 2010, what is the difference between the Aid flow (current US$) in Europe(all income levels) and Aid flow (current US$) in Sub-Saharan Africa (all income levels)?
Your response must be concise. -1.06e+07. In the year 2010, what is the difference between the Aid flow (current US$) of Europe(all income levels) and Aid flow (current US$) of Uganda?
Offer a terse response. -2.52e+06. In the year 2010, what is the difference between the Aid flow (current US$) in Low income and Aid flow (current US$) in Uganda?
Provide a short and direct response. 7.98e+06. In the year 2010, what is the difference between the Aid flow (current US$) in Sub-Saharan Africa (all income levels) and Aid flow (current US$) in Uganda?
Your answer should be very brief. 8.03e+06. What is the ratio of the Aid flow (current US$) in Europe(all income levels) in 2003 to that in 2004?
Ensure brevity in your answer.  1.2. What is the ratio of the Aid flow (current US$) of Low income in 2003 to that in 2004?
Make the answer very short. 0.83. What is the ratio of the Aid flow (current US$) in Sub-Saharan Africa (all income levels) in 2003 to that in 2004?
Ensure brevity in your answer.  0.82. What is the ratio of the Aid flow (current US$) of Uganda in 2003 to that in 2004?
Make the answer very short. 0.79. What is the ratio of the Aid flow (current US$) of Europe(all income levels) in 2003 to that in 2005?
Your response must be concise. 0.27. What is the ratio of the Aid flow (current US$) in Low income in 2003 to that in 2005?
Offer a terse response. 0.48. What is the ratio of the Aid flow (current US$) in Sub-Saharan Africa (all income levels) in 2003 to that in 2005?
Make the answer very short. 0.72. What is the ratio of the Aid flow (current US$) of Uganda in 2003 to that in 2005?
Your response must be concise. 0.6. What is the ratio of the Aid flow (current US$) of Europe(all income levels) in 2003 to that in 2006?
Keep it short and to the point. 0.21. What is the ratio of the Aid flow (current US$) in Low income in 2003 to that in 2006?
Provide a succinct answer. 0.3. What is the ratio of the Aid flow (current US$) in Sub-Saharan Africa (all income levels) in 2003 to that in 2006?
Your response must be concise. 0.46. What is the ratio of the Aid flow (current US$) in Uganda in 2003 to that in 2006?
Ensure brevity in your answer.  0.42. What is the ratio of the Aid flow (current US$) in Europe(all income levels) in 2003 to that in 2007?
Ensure brevity in your answer.  0.09. What is the ratio of the Aid flow (current US$) of Low income in 2003 to that in 2007?
Offer a very short reply. 0.26. What is the ratio of the Aid flow (current US$) of Sub-Saharan Africa (all income levels) in 2003 to that in 2007?
Offer a very short reply. 0.41. What is the ratio of the Aid flow (current US$) of Uganda in 2003 to that in 2007?
Keep it short and to the point. 0.38. What is the ratio of the Aid flow (current US$) in Europe(all income levels) in 2003 to that in 2008?
Your answer should be very brief. 0.09. What is the ratio of the Aid flow (current US$) in Low income in 2003 to that in 2008?
Your answer should be very brief. 0.25. What is the ratio of the Aid flow (current US$) of Sub-Saharan Africa (all income levels) in 2003 to that in 2008?
Make the answer very short. 0.3. What is the ratio of the Aid flow (current US$) of Europe(all income levels) in 2003 to that in 2009?
Provide a succinct answer. 0.14. What is the ratio of the Aid flow (current US$) in Low income in 2003 to that in 2009?
Your response must be concise. 0.34. What is the ratio of the Aid flow (current US$) in Sub-Saharan Africa (all income levels) in 2003 to that in 2009?
Your answer should be compact. 0.38. What is the ratio of the Aid flow (current US$) of Uganda in 2003 to that in 2009?
Your answer should be very brief. 0.3. What is the ratio of the Aid flow (current US$) of Europe(all income levels) in 2003 to that in 2010?
Offer a very short reply. 0.11. What is the ratio of the Aid flow (current US$) in Low income in 2003 to that in 2010?
Ensure brevity in your answer.  0.36. What is the ratio of the Aid flow (current US$) of Sub-Saharan Africa (all income levels) in 2003 to that in 2010?
Give a very brief answer. 0.45. What is the ratio of the Aid flow (current US$) in Uganda in 2003 to that in 2010?
Offer a terse response. 0.31. What is the ratio of the Aid flow (current US$) in Europe(all income levels) in 2004 to that in 2005?
Provide a short and direct response. 0.23. What is the ratio of the Aid flow (current US$) of Low income in 2004 to that in 2005?
Your answer should be very brief. 0.57. What is the ratio of the Aid flow (current US$) in Sub-Saharan Africa (all income levels) in 2004 to that in 2005?
Offer a very short reply. 0.87. What is the ratio of the Aid flow (current US$) of Uganda in 2004 to that in 2005?
Provide a succinct answer. 0.76. What is the ratio of the Aid flow (current US$) in Europe(all income levels) in 2004 to that in 2006?
Offer a very short reply. 0.18. What is the ratio of the Aid flow (current US$) in Low income in 2004 to that in 2006?
Provide a short and direct response. 0.37. What is the ratio of the Aid flow (current US$) in Sub-Saharan Africa (all income levels) in 2004 to that in 2006?
Your answer should be compact. 0.56. What is the ratio of the Aid flow (current US$) of Uganda in 2004 to that in 2006?
Your answer should be compact. 0.54. What is the ratio of the Aid flow (current US$) of Europe(all income levels) in 2004 to that in 2007?
Give a very brief answer. 0.08. What is the ratio of the Aid flow (current US$) of Low income in 2004 to that in 2007?
Your response must be concise. 0.32. What is the ratio of the Aid flow (current US$) in Uganda in 2004 to that in 2007?
Your answer should be very brief. 0.48. What is the ratio of the Aid flow (current US$) in Europe(all income levels) in 2004 to that in 2008?
Make the answer very short. 0.07. What is the ratio of the Aid flow (current US$) of Low income in 2004 to that in 2008?
Your answer should be compact. 0.3. What is the ratio of the Aid flow (current US$) of Sub-Saharan Africa (all income levels) in 2004 to that in 2008?
Offer a terse response. 0.37. What is the ratio of the Aid flow (current US$) in Uganda in 2004 to that in 2008?
Provide a short and direct response. 0.38. What is the ratio of the Aid flow (current US$) of Europe(all income levels) in 2004 to that in 2009?
Your answer should be compact. 0.12. What is the ratio of the Aid flow (current US$) of Low income in 2004 to that in 2009?
Offer a very short reply. 0.41. What is the ratio of the Aid flow (current US$) in Sub-Saharan Africa (all income levels) in 2004 to that in 2009?
Your response must be concise. 0.46. What is the ratio of the Aid flow (current US$) of Uganda in 2004 to that in 2009?
Your response must be concise. 0.38. What is the ratio of the Aid flow (current US$) in Europe(all income levels) in 2004 to that in 2010?
Provide a succinct answer. 0.09. What is the ratio of the Aid flow (current US$) in Low income in 2004 to that in 2010?
Provide a short and direct response. 0.43. What is the ratio of the Aid flow (current US$) in Sub-Saharan Africa (all income levels) in 2004 to that in 2010?
Provide a succinct answer. 0.54. What is the ratio of the Aid flow (current US$) of Uganda in 2004 to that in 2010?
Your answer should be compact. 0.4. What is the ratio of the Aid flow (current US$) in Europe(all income levels) in 2005 to that in 2006?
Your response must be concise. 0.79. What is the ratio of the Aid flow (current US$) in Low income in 2005 to that in 2006?
Provide a succinct answer. 0.64. What is the ratio of the Aid flow (current US$) in Sub-Saharan Africa (all income levels) in 2005 to that in 2006?
Give a very brief answer. 0.65. What is the ratio of the Aid flow (current US$) in Uganda in 2005 to that in 2006?
Offer a very short reply. 0.71. What is the ratio of the Aid flow (current US$) of Low income in 2005 to that in 2007?
Ensure brevity in your answer.  0.55. What is the ratio of the Aid flow (current US$) in Sub-Saharan Africa (all income levels) in 2005 to that in 2007?
Offer a terse response. 0.57. What is the ratio of the Aid flow (current US$) in Uganda in 2005 to that in 2007?
Keep it short and to the point. 0.63. What is the ratio of the Aid flow (current US$) in Europe(all income levels) in 2005 to that in 2008?
Offer a terse response. 0.31. What is the ratio of the Aid flow (current US$) in Low income in 2005 to that in 2008?
Provide a short and direct response. 0.52. What is the ratio of the Aid flow (current US$) in Sub-Saharan Africa (all income levels) in 2005 to that in 2008?
Make the answer very short. 0.42. What is the ratio of the Aid flow (current US$) of Uganda in 2005 to that in 2008?
Keep it short and to the point. 0.5. What is the ratio of the Aid flow (current US$) in Europe(all income levels) in 2005 to that in 2009?
Make the answer very short. 0.51. What is the ratio of the Aid flow (current US$) in Low income in 2005 to that in 2009?
Your answer should be very brief. 0.71. What is the ratio of the Aid flow (current US$) in Sub-Saharan Africa (all income levels) in 2005 to that in 2009?
Give a very brief answer. 0.53. What is the ratio of the Aid flow (current US$) of Uganda in 2005 to that in 2009?
Offer a very short reply. 0.51. What is the ratio of the Aid flow (current US$) in Low income in 2005 to that in 2010?
Ensure brevity in your answer.  0.75. What is the ratio of the Aid flow (current US$) in Sub-Saharan Africa (all income levels) in 2005 to that in 2010?
Your response must be concise. 0.62. What is the ratio of the Aid flow (current US$) of Uganda in 2005 to that in 2010?
Your answer should be compact. 0.52. What is the ratio of the Aid flow (current US$) in Europe(all income levels) in 2006 to that in 2007?
Offer a very short reply. 0.42. What is the ratio of the Aid flow (current US$) in Low income in 2006 to that in 2007?
Make the answer very short. 0.87. What is the ratio of the Aid flow (current US$) in Sub-Saharan Africa (all income levels) in 2006 to that in 2007?
Offer a terse response. 0.89. What is the ratio of the Aid flow (current US$) of Uganda in 2006 to that in 2007?
Offer a very short reply. 0.89. What is the ratio of the Aid flow (current US$) of Europe(all income levels) in 2006 to that in 2008?
Provide a short and direct response. 0.4. What is the ratio of the Aid flow (current US$) in Low income in 2006 to that in 2008?
Keep it short and to the point. 0.82. What is the ratio of the Aid flow (current US$) of Sub-Saharan Africa (all income levels) in 2006 to that in 2008?
Offer a terse response. 0.66. What is the ratio of the Aid flow (current US$) in Uganda in 2006 to that in 2008?
Your response must be concise. 0.71. What is the ratio of the Aid flow (current US$) in Europe(all income levels) in 2006 to that in 2009?
Provide a succinct answer. 0.65. What is the ratio of the Aid flow (current US$) in Low income in 2006 to that in 2009?
Your answer should be compact. 1.11. What is the ratio of the Aid flow (current US$) of Sub-Saharan Africa (all income levels) in 2006 to that in 2009?
Offer a terse response. 0.82. What is the ratio of the Aid flow (current US$) in Uganda in 2006 to that in 2009?
Keep it short and to the point. 0.72. What is the ratio of the Aid flow (current US$) in Europe(all income levels) in 2006 to that in 2010?
Offer a terse response. 0.51. What is the ratio of the Aid flow (current US$) of Low income in 2006 to that in 2010?
Offer a terse response. 1.17. What is the ratio of the Aid flow (current US$) of Sub-Saharan Africa (all income levels) in 2006 to that in 2010?
Provide a short and direct response. 0.96. What is the ratio of the Aid flow (current US$) of Uganda in 2006 to that in 2010?
Provide a succinct answer. 0.74. What is the ratio of the Aid flow (current US$) of Europe(all income levels) in 2007 to that in 2008?
Offer a very short reply. 0.94. What is the ratio of the Aid flow (current US$) of Low income in 2007 to that in 2008?
Make the answer very short. 0.94. What is the ratio of the Aid flow (current US$) in Sub-Saharan Africa (all income levels) in 2007 to that in 2008?
Your answer should be very brief. 0.74. What is the ratio of the Aid flow (current US$) in Europe(all income levels) in 2007 to that in 2009?
Offer a very short reply. 1.53. What is the ratio of the Aid flow (current US$) of Low income in 2007 to that in 2009?
Provide a succinct answer. 1.28. What is the ratio of the Aid flow (current US$) in Sub-Saharan Africa (all income levels) in 2007 to that in 2009?
Provide a succinct answer. 0.92. What is the ratio of the Aid flow (current US$) in Uganda in 2007 to that in 2009?
Provide a short and direct response. 0.81. What is the ratio of the Aid flow (current US$) in Low income in 2007 to that in 2010?
Offer a very short reply. 1.35. What is the ratio of the Aid flow (current US$) in Sub-Saharan Africa (all income levels) in 2007 to that in 2010?
Your answer should be very brief. 1.08. What is the ratio of the Aid flow (current US$) in Uganda in 2007 to that in 2010?
Your response must be concise. 0.83. What is the ratio of the Aid flow (current US$) of Europe(all income levels) in 2008 to that in 2009?
Provide a short and direct response. 1.63. What is the ratio of the Aid flow (current US$) of Low income in 2008 to that in 2009?
Give a very brief answer. 1.36. What is the ratio of the Aid flow (current US$) of Sub-Saharan Africa (all income levels) in 2008 to that in 2009?
Your answer should be compact. 1.24. What is the ratio of the Aid flow (current US$) in Uganda in 2008 to that in 2009?
Keep it short and to the point. 1.01. What is the ratio of the Aid flow (current US$) of Europe(all income levels) in 2008 to that in 2010?
Make the answer very short. 1.27. What is the ratio of the Aid flow (current US$) of Low income in 2008 to that in 2010?
Your answer should be very brief. 1.44. What is the ratio of the Aid flow (current US$) in Sub-Saharan Africa (all income levels) in 2008 to that in 2010?
Your response must be concise. 1.46. What is the ratio of the Aid flow (current US$) in Uganda in 2008 to that in 2010?
Give a very brief answer. 1.04. What is the ratio of the Aid flow (current US$) of Europe(all income levels) in 2009 to that in 2010?
Give a very brief answer. 0.78. What is the ratio of the Aid flow (current US$) in Low income in 2009 to that in 2010?
Keep it short and to the point. 1.06. What is the ratio of the Aid flow (current US$) of Sub-Saharan Africa (all income levels) in 2009 to that in 2010?
Your response must be concise. 1.18. What is the ratio of the Aid flow (current US$) in Uganda in 2009 to that in 2010?
Ensure brevity in your answer.  1.03. What is the difference between the highest and the second highest Aid flow (current US$) in Europe(all income levels)?
Keep it short and to the point. 4.00e+04. What is the difference between the highest and the second highest Aid flow (current US$) of Low income?
Your answer should be compact. 9.10e+05. What is the difference between the highest and the second highest Aid flow (current US$) of Sub-Saharan Africa (all income levels)?
Keep it short and to the point. 3.15e+06. What is the difference between the highest and the second highest Aid flow (current US$) in Uganda?
Give a very brief answer. 3.00e+04. What is the difference between the highest and the lowest Aid flow (current US$) in Europe(all income levels)?
Keep it short and to the point. 6.50e+05. What is the difference between the highest and the lowest Aid flow (current US$) of Low income?
Offer a very short reply. 1.19e+07. What is the difference between the highest and the lowest Aid flow (current US$) of Sub-Saharan Africa (all income levels)?
Your answer should be compact. 1.13e+07. What is the difference between the highest and the lowest Aid flow (current US$) in Uganda?
Your answer should be very brief. 2.24e+06. 